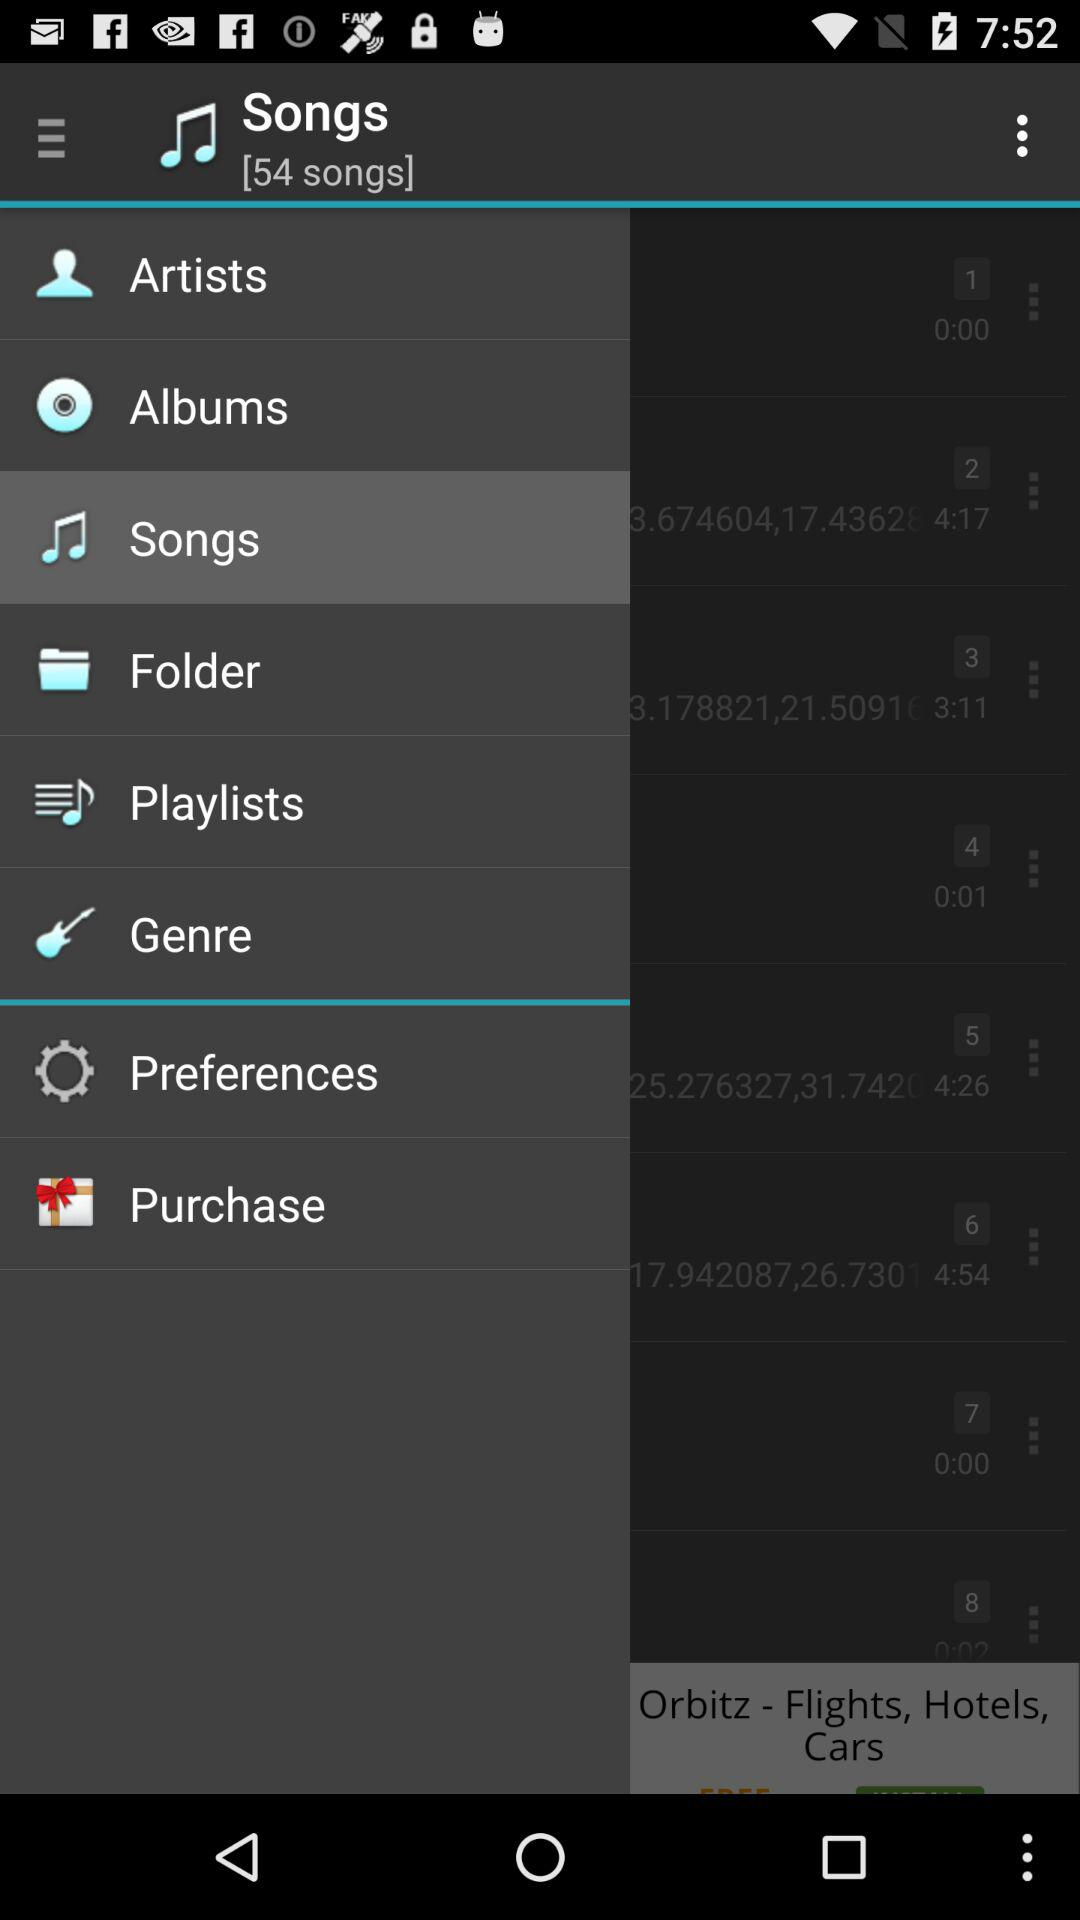How many items have a duration of more than 4 minutes?
Answer the question using a single word or phrase. 3 